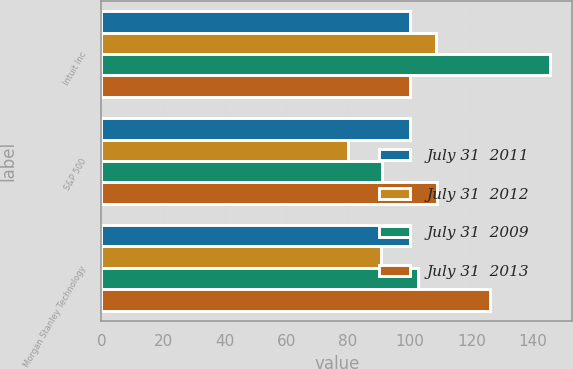<chart> <loc_0><loc_0><loc_500><loc_500><stacked_bar_chart><ecel><fcel>Intuit Inc<fcel>S&P 500<fcel>Morgan Stanley Technology<nl><fcel>July 31  2011<fcel>100<fcel>100<fcel>100<nl><fcel>July 31  2012<fcel>108.67<fcel>80.04<fcel>90.7<nl><fcel>July 31  2009<fcel>145.44<fcel>91.11<fcel>102.64<nl><fcel>July 31  2013<fcel>100<fcel>109.02<fcel>125.99<nl></chart> 